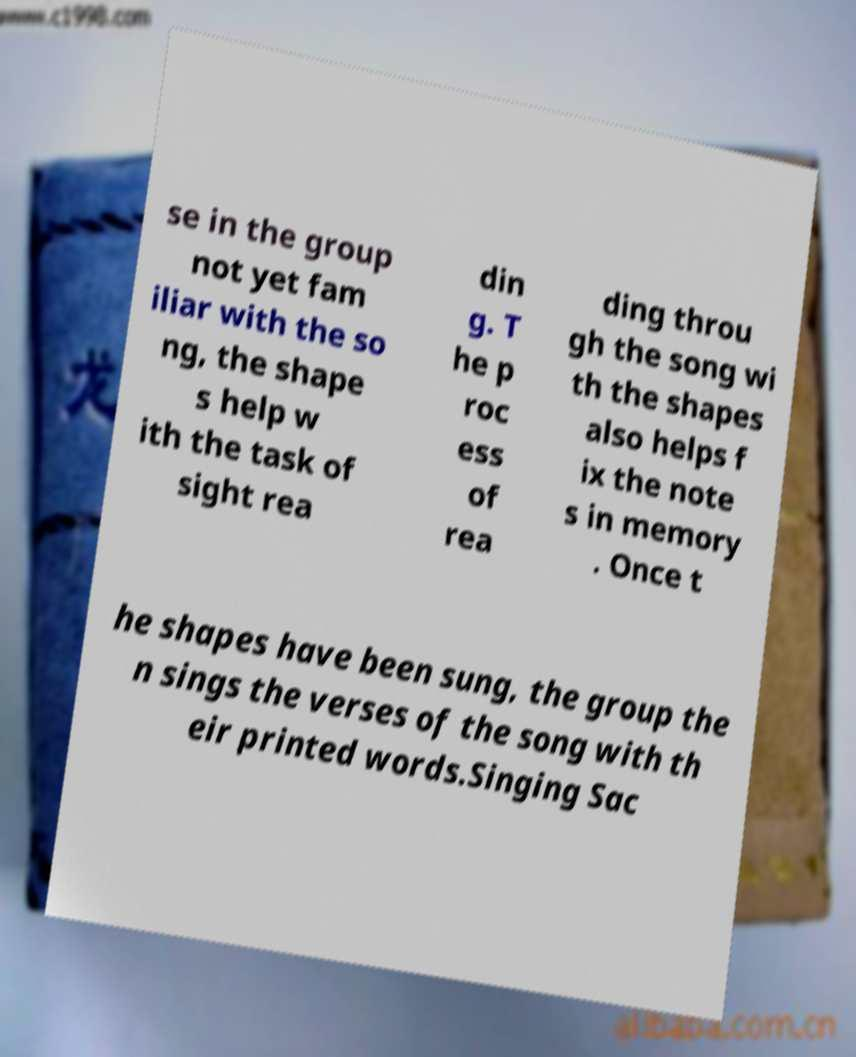For documentation purposes, I need the text within this image transcribed. Could you provide that? se in the group not yet fam iliar with the so ng, the shape s help w ith the task of sight rea din g. T he p roc ess of rea ding throu gh the song wi th the shapes also helps f ix the note s in memory . Once t he shapes have been sung, the group the n sings the verses of the song with th eir printed words.Singing Sac 